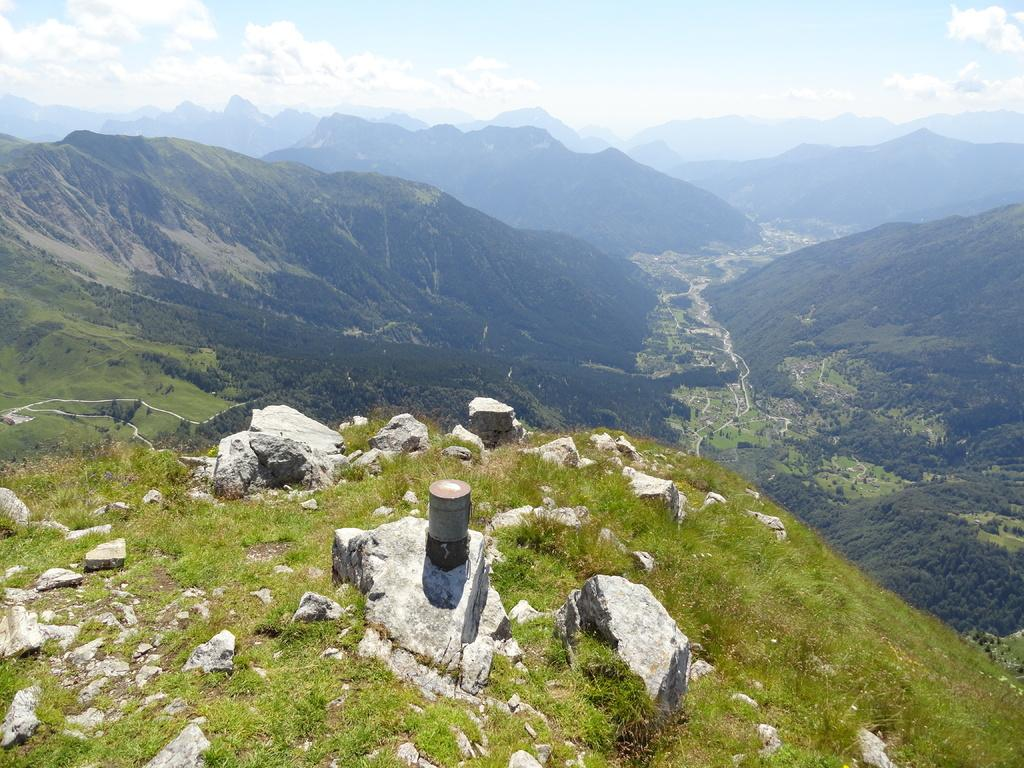What type of natural landscape is depicted in the image? The image features forest mountains. How would you describe the sky in the image? The sky is slightly cloudy and blue at the top of the image. What type of terrain is visible at the bottom of the image? There is grassy land at the bottom of the image. What color of paint is used on the window in the image? There is no window present in the image; it features forest mountains, a slightly cloudy and blue sky, and grassy land. How many leaves can be seen on the tree in the image? There is no tree with leaves present in the image; it only features forest mountains, a slightly cloudy and blue sky, and grassy land. 